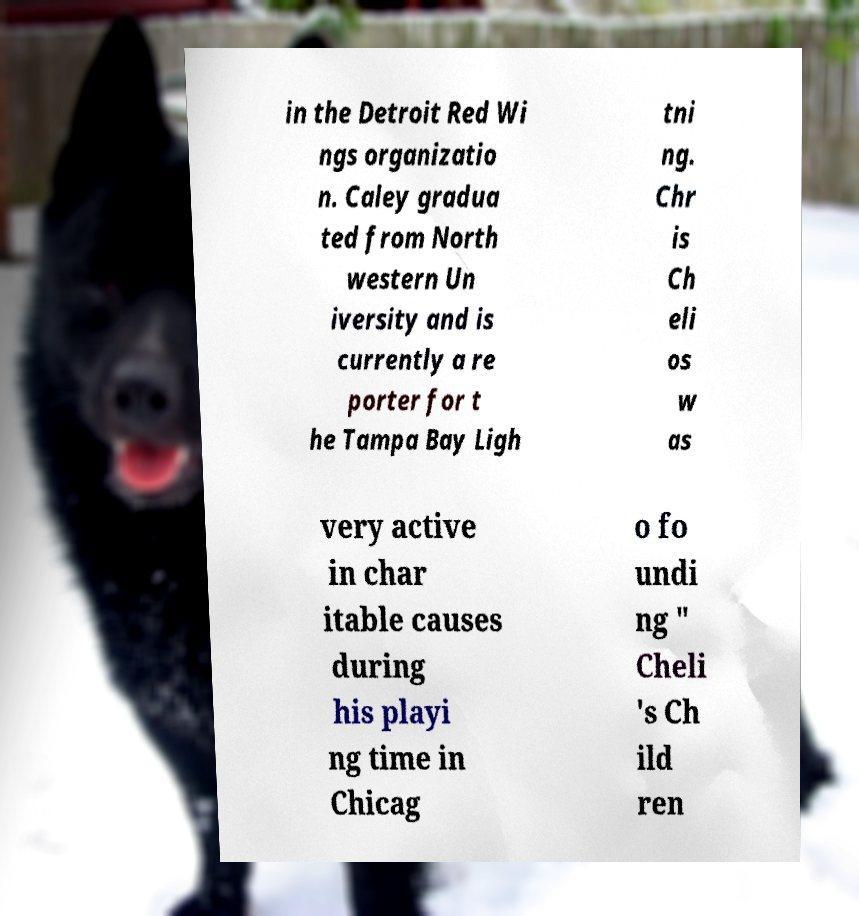There's text embedded in this image that I need extracted. Can you transcribe it verbatim? in the Detroit Red Wi ngs organizatio n. Caley gradua ted from North western Un iversity and is currently a re porter for t he Tampa Bay Ligh tni ng. Chr is Ch eli os w as very active in char itable causes during his playi ng time in Chicag o fo undi ng " Cheli 's Ch ild ren 